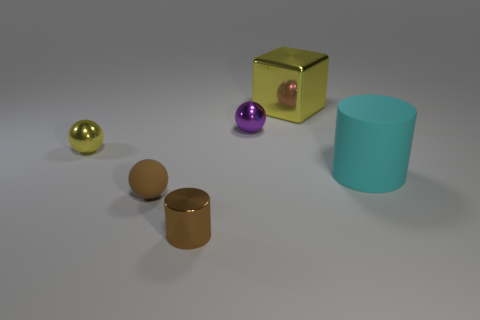Add 4 big purple cylinders. How many objects exist? 10 Subtract all cylinders. How many objects are left? 4 Subtract all tiny gray cylinders. Subtract all tiny yellow spheres. How many objects are left? 5 Add 2 rubber cylinders. How many rubber cylinders are left? 3 Add 5 big rubber cylinders. How many big rubber cylinders exist? 6 Subtract 0 cyan cubes. How many objects are left? 6 